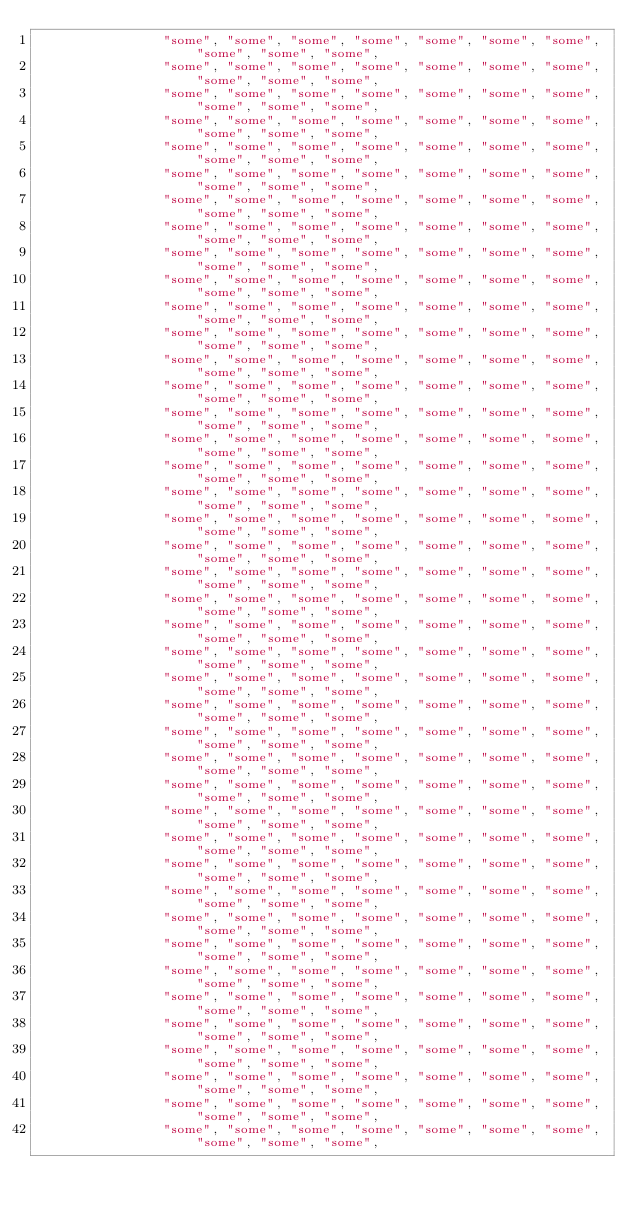Convert code to text. <code><loc_0><loc_0><loc_500><loc_500><_Rust_>                "some", "some", "some", "some", "some", "some", "some", "some", "some", "some",
                "some", "some", "some", "some", "some", "some", "some", "some", "some", "some",
                "some", "some", "some", "some", "some", "some", "some", "some", "some", "some",
                "some", "some", "some", "some", "some", "some", "some", "some", "some", "some",
                "some", "some", "some", "some", "some", "some", "some", "some", "some", "some",
                "some", "some", "some", "some", "some", "some", "some", "some", "some", "some",
                "some", "some", "some", "some", "some", "some", "some", "some", "some", "some",
                "some", "some", "some", "some", "some", "some", "some", "some", "some", "some",
                "some", "some", "some", "some", "some", "some", "some", "some", "some", "some",
                "some", "some", "some", "some", "some", "some", "some", "some", "some", "some",
                "some", "some", "some", "some", "some", "some", "some", "some", "some", "some",
                "some", "some", "some", "some", "some", "some", "some", "some", "some", "some",
                "some", "some", "some", "some", "some", "some", "some", "some", "some", "some",
                "some", "some", "some", "some", "some", "some", "some", "some", "some", "some",
                "some", "some", "some", "some", "some", "some", "some", "some", "some", "some",
                "some", "some", "some", "some", "some", "some", "some", "some", "some", "some",
                "some", "some", "some", "some", "some", "some", "some", "some", "some", "some",
                "some", "some", "some", "some", "some", "some", "some", "some", "some", "some",
                "some", "some", "some", "some", "some", "some", "some", "some", "some", "some",
                "some", "some", "some", "some", "some", "some", "some", "some", "some", "some",
                "some", "some", "some", "some", "some", "some", "some", "some", "some", "some",
                "some", "some", "some", "some", "some", "some", "some", "some", "some", "some",
                "some", "some", "some", "some", "some", "some", "some", "some", "some", "some",
                "some", "some", "some", "some", "some", "some", "some", "some", "some", "some",
                "some", "some", "some", "some", "some", "some", "some", "some", "some", "some",
                "some", "some", "some", "some", "some", "some", "some", "some", "some", "some",
                "some", "some", "some", "some", "some", "some", "some", "some", "some", "some",
                "some", "some", "some", "some", "some", "some", "some", "some", "some", "some",
                "some", "some", "some", "some", "some", "some", "some", "some", "some", "some",
                "some", "some", "some", "some", "some", "some", "some", "some", "some", "some",
                "some", "some", "some", "some", "some", "some", "some", "some", "some", "some",
                "some", "some", "some", "some", "some", "some", "some", "some", "some", "some",
                "some", "some", "some", "some", "some", "some", "some", "some", "some", "some",
                "some", "some", "some", "some", "some", "some", "some", "some", "some", "some",
                "some", "some", "some", "some", "some", "some", "some", "some", "some", "some",
                "some", "some", "some", "some", "some", "some", "some", "some", "some", "some",
                "some", "some", "some", "some", "some", "some", "some", "some", "some", "some",
                "some", "some", "some", "some", "some", "some", "some", "some", "some", "some",
                "some", "some", "some", "some", "some", "some", "some", "some", "some", "some",
                "some", "some", "some", "some", "some", "some", "some", "some", "some", "some",
                "some", "some", "some", "some", "some", "some", "some", "some", "some", "some",
                "some", "some", "some", "some", "some", "some", "some", "some", "some", "some",</code> 